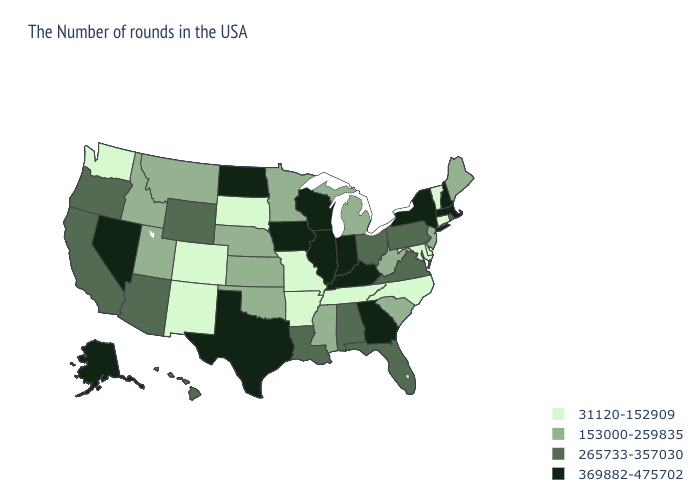Name the states that have a value in the range 265733-357030?
Answer briefly. Rhode Island, Pennsylvania, Virginia, Ohio, Florida, Alabama, Louisiana, Wyoming, Arizona, California, Oregon, Hawaii. Name the states that have a value in the range 153000-259835?
Keep it brief. Maine, New Jersey, South Carolina, West Virginia, Michigan, Mississippi, Minnesota, Kansas, Nebraska, Oklahoma, Utah, Montana, Idaho. Among the states that border Louisiana , does Arkansas have the highest value?
Keep it brief. No. Name the states that have a value in the range 265733-357030?
Keep it brief. Rhode Island, Pennsylvania, Virginia, Ohio, Florida, Alabama, Louisiana, Wyoming, Arizona, California, Oregon, Hawaii. What is the lowest value in the West?
Quick response, please. 31120-152909. Name the states that have a value in the range 153000-259835?
Concise answer only. Maine, New Jersey, South Carolina, West Virginia, Michigan, Mississippi, Minnesota, Kansas, Nebraska, Oklahoma, Utah, Montana, Idaho. What is the highest value in states that border Florida?
Give a very brief answer. 369882-475702. What is the lowest value in the MidWest?
Answer briefly. 31120-152909. What is the lowest value in the MidWest?
Give a very brief answer. 31120-152909. Is the legend a continuous bar?
Answer briefly. No. Does the map have missing data?
Concise answer only. No. What is the lowest value in the South?
Give a very brief answer. 31120-152909. Which states have the lowest value in the MidWest?
Be succinct. Missouri, South Dakota. Does Ohio have the highest value in the MidWest?
Quick response, please. No. Does the first symbol in the legend represent the smallest category?
Write a very short answer. Yes. 